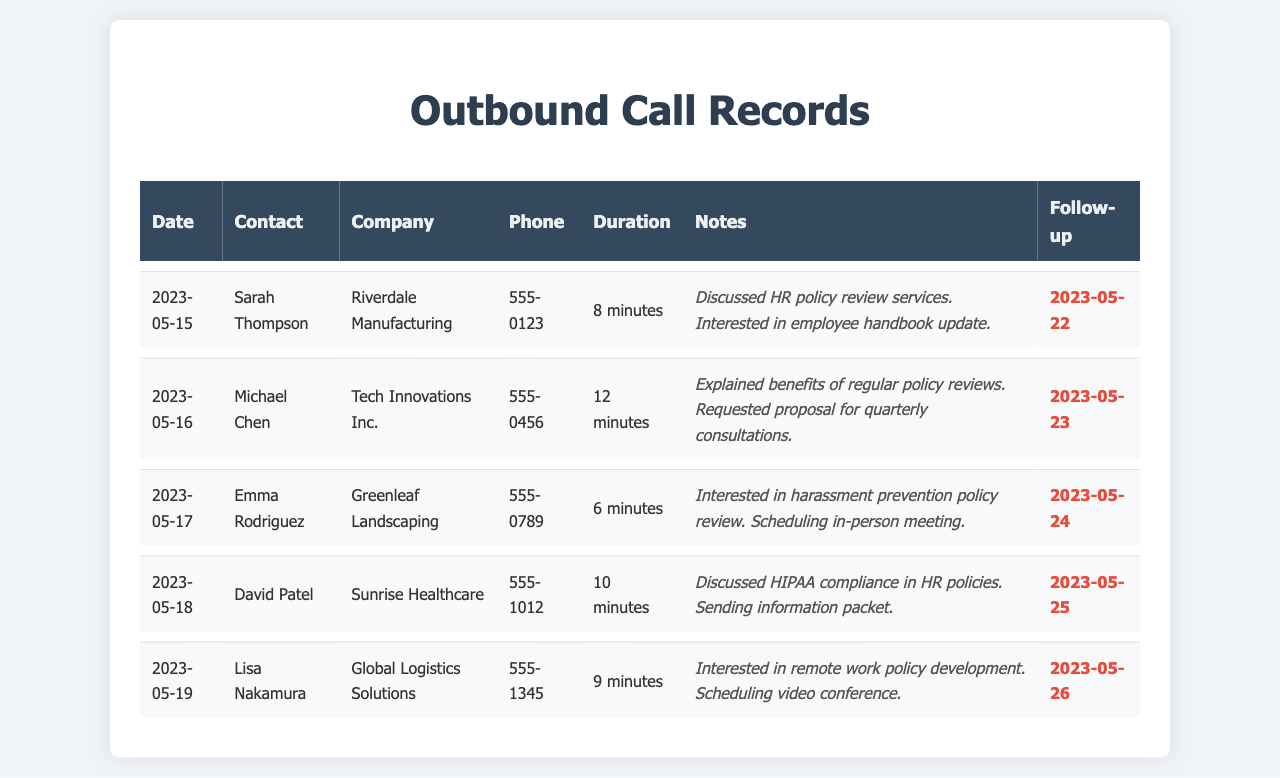What date was the call with Sarah Thompson? The call with Sarah Thompson occurred on 2023-05-15, as indicated in the records.
Answer: 2023-05-15 What is the follow-up date for the conversation with Michael Chen? The follow-up date noted after the conversation with Michael Chen is 2023-05-23.
Answer: 2023-05-23 How many minutes did the call with Emma Rodriguez last? The call with Emma Rodriguez lasted for 6 minutes, as mentioned in the duration column.
Answer: 6 minutes What policy was discussed during the call with David Patel? The discussed policy during the conversation with David Patel was HIPAA compliance in HR policies.
Answer: HIPAA compliance Who is interested in remote work policy development? Lisa Nakamura from Global Logistics Solutions expressed interest in the development of a remote work policy.
Answer: Lisa Nakamura Which company had a call on May 18th? The company that had a call on May 18th is Sunrise Healthcare, as shown in the records.
Answer: Sunrise Healthcare What was the main topic of the discussion with Sarah Thompson? The main topic of the discussion with Sarah Thompson was the HR policy review services and an employee handbook update.
Answer: HR policy review services What is the phone number for Tech Innovations Inc.? The phone number for Tech Innovations Inc. is 555-0456, as listed in the document.
Answer: 555-0456 How many calls are recorded in total? There are a total of 5 calls recorded in the document.
Answer: 5 calls 